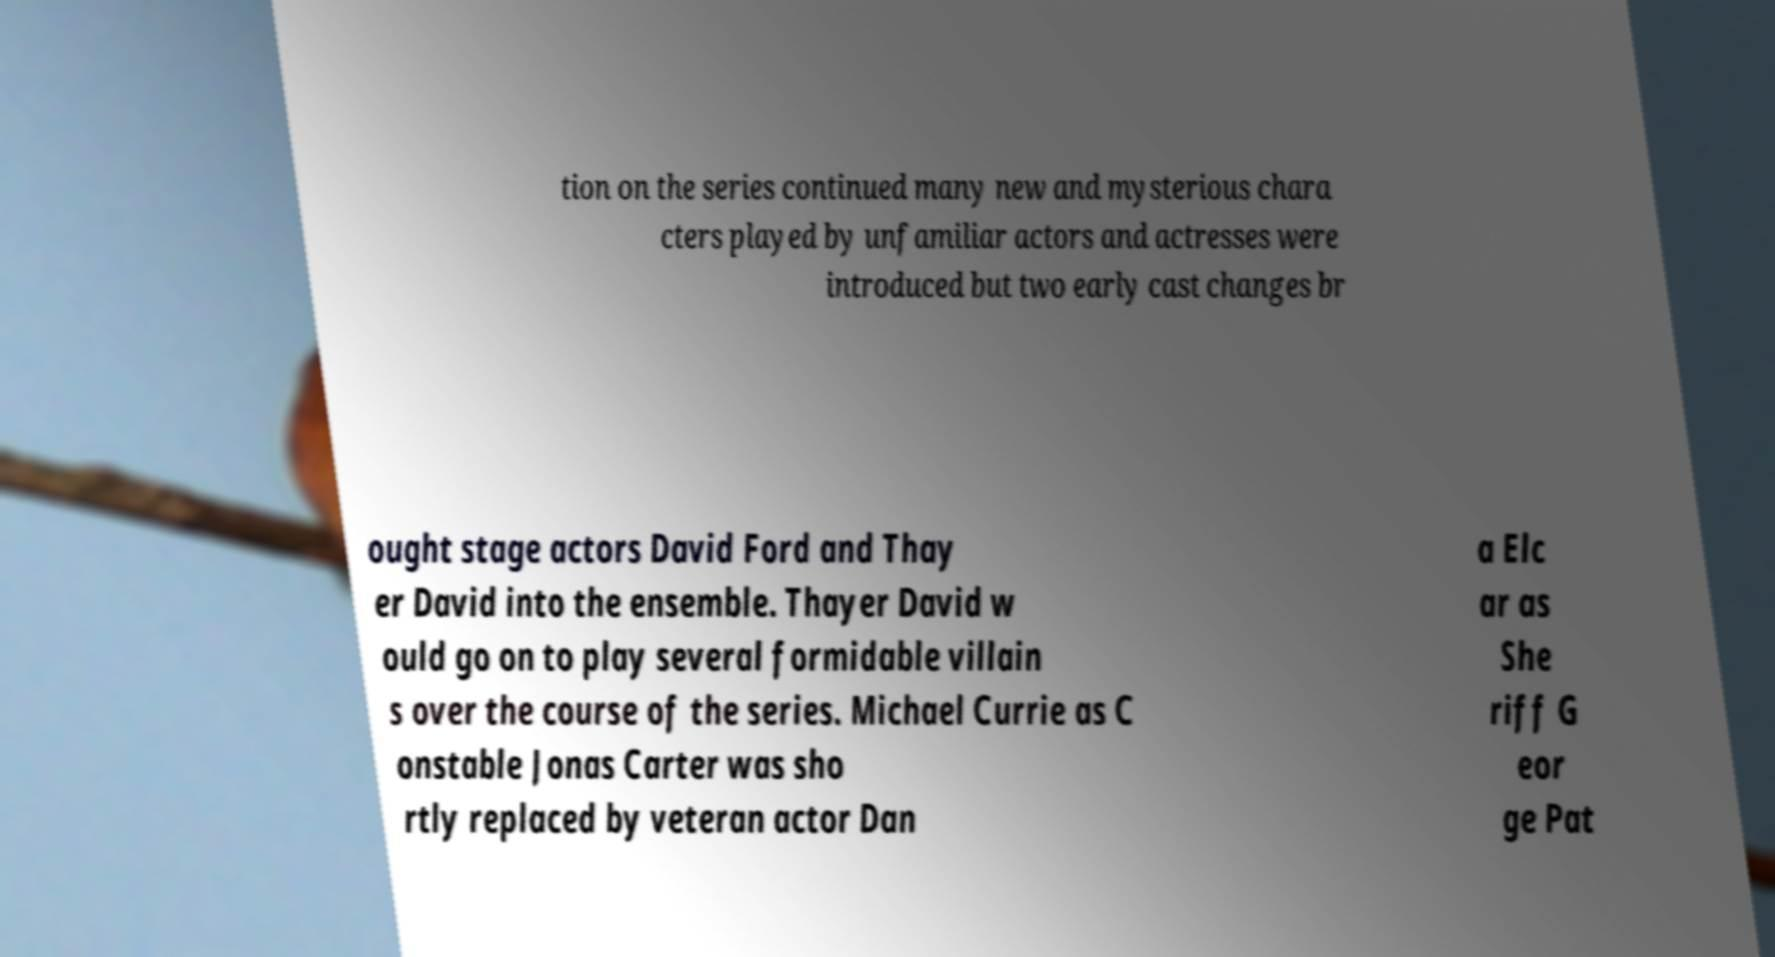There's text embedded in this image that I need extracted. Can you transcribe it verbatim? tion on the series continued many new and mysterious chara cters played by unfamiliar actors and actresses were introduced but two early cast changes br ought stage actors David Ford and Thay er David into the ensemble. Thayer David w ould go on to play several formidable villain s over the course of the series. Michael Currie as C onstable Jonas Carter was sho rtly replaced by veteran actor Dan a Elc ar as She riff G eor ge Pat 